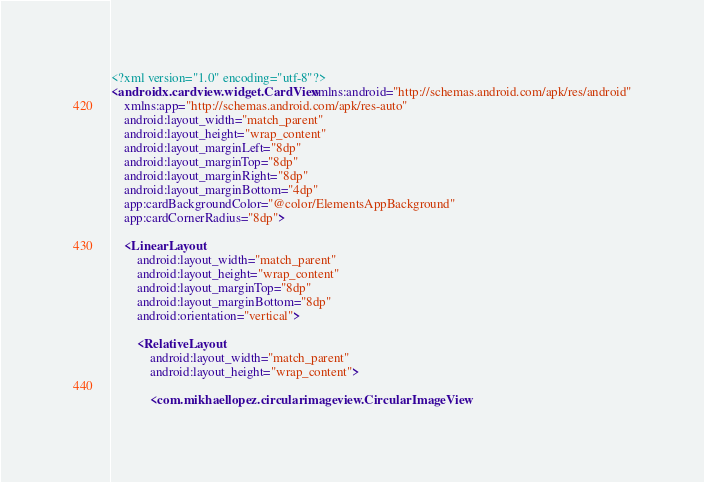<code> <loc_0><loc_0><loc_500><loc_500><_XML_><?xml version="1.0" encoding="utf-8"?>
<androidx.cardview.widget.CardView xmlns:android="http://schemas.android.com/apk/res/android"
    xmlns:app="http://schemas.android.com/apk/res-auto"
    android:layout_width="match_parent"
    android:layout_height="wrap_content"
    android:layout_marginLeft="8dp"
    android:layout_marginTop="8dp"
    android:layout_marginRight="8dp"
    android:layout_marginBottom="4dp"
    app:cardBackgroundColor="@color/ElementsAppBackground"
    app:cardCornerRadius="8dp">

    <LinearLayout
        android:layout_width="match_parent"
        android:layout_height="wrap_content"
        android:layout_marginTop="8dp"
        android:layout_marginBottom="8dp"
        android:orientation="vertical">

        <RelativeLayout
            android:layout_width="match_parent"
            android:layout_height="wrap_content">

            <com.mikhaellopez.circularimageview.CircularImageView</code> 